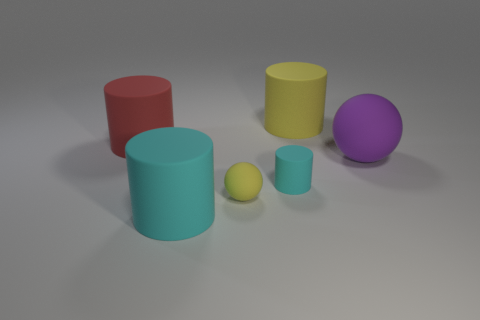Subtract all red cylinders. How many cylinders are left? 3 Subtract all brown cylinders. Subtract all gray cubes. How many cylinders are left? 4 Add 1 large purple spheres. How many objects exist? 7 Subtract all cylinders. How many objects are left? 2 Subtract all big cyan matte cylinders. Subtract all yellow matte objects. How many objects are left? 3 Add 3 yellow cylinders. How many yellow cylinders are left? 4 Add 5 yellow matte spheres. How many yellow matte spheres exist? 6 Subtract 0 red balls. How many objects are left? 6 